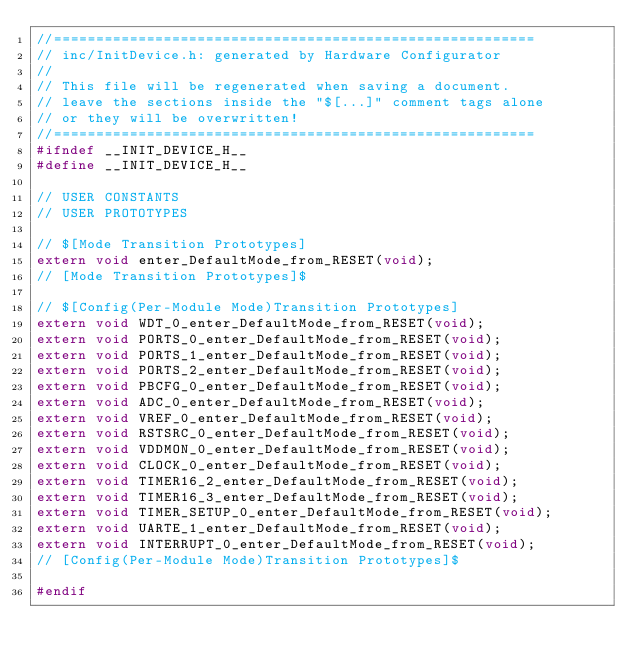Convert code to text. <code><loc_0><loc_0><loc_500><loc_500><_C_>//=========================================================
// inc/InitDevice.h: generated by Hardware Configurator
//
// This file will be regenerated when saving a document.
// leave the sections inside the "$[...]" comment tags alone
// or they will be overwritten!
//=========================================================
#ifndef __INIT_DEVICE_H__
#define __INIT_DEVICE_H__

// USER CONSTANTS
// USER PROTOTYPES

// $[Mode Transition Prototypes]
extern void enter_DefaultMode_from_RESET(void);
// [Mode Transition Prototypes]$

// $[Config(Per-Module Mode)Transition Prototypes]
extern void WDT_0_enter_DefaultMode_from_RESET(void);
extern void PORTS_0_enter_DefaultMode_from_RESET(void);
extern void PORTS_1_enter_DefaultMode_from_RESET(void);
extern void PORTS_2_enter_DefaultMode_from_RESET(void);
extern void PBCFG_0_enter_DefaultMode_from_RESET(void);
extern void ADC_0_enter_DefaultMode_from_RESET(void);
extern void VREF_0_enter_DefaultMode_from_RESET(void);
extern void RSTSRC_0_enter_DefaultMode_from_RESET(void);
extern void VDDMON_0_enter_DefaultMode_from_RESET(void);
extern void CLOCK_0_enter_DefaultMode_from_RESET(void);
extern void TIMER16_2_enter_DefaultMode_from_RESET(void);
extern void TIMER16_3_enter_DefaultMode_from_RESET(void);
extern void TIMER_SETUP_0_enter_DefaultMode_from_RESET(void);
extern void UARTE_1_enter_DefaultMode_from_RESET(void);
extern void INTERRUPT_0_enter_DefaultMode_from_RESET(void);
// [Config(Per-Module Mode)Transition Prototypes]$

#endif

</code> 